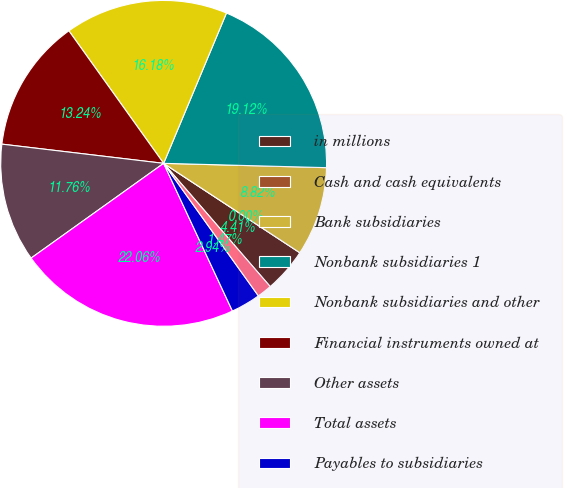Convert chart to OTSL. <chart><loc_0><loc_0><loc_500><loc_500><pie_chart><fcel>in millions<fcel>Cash and cash equivalents<fcel>Bank subsidiaries<fcel>Nonbank subsidiaries 1<fcel>Nonbank subsidiaries and other<fcel>Financial instruments owned at<fcel>Other assets<fcel>Total assets<fcel>Payables to subsidiaries<fcel>Financial instruments sold but<nl><fcel>4.41%<fcel>0.0%<fcel>8.82%<fcel>19.12%<fcel>16.18%<fcel>13.24%<fcel>11.76%<fcel>22.06%<fcel>2.94%<fcel>1.47%<nl></chart> 